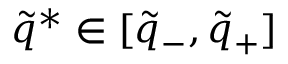Convert formula to latex. <formula><loc_0><loc_0><loc_500><loc_500>\tilde { q } ^ { * } \in [ \tilde { q } _ { - } , \tilde { q } _ { + } ]</formula> 